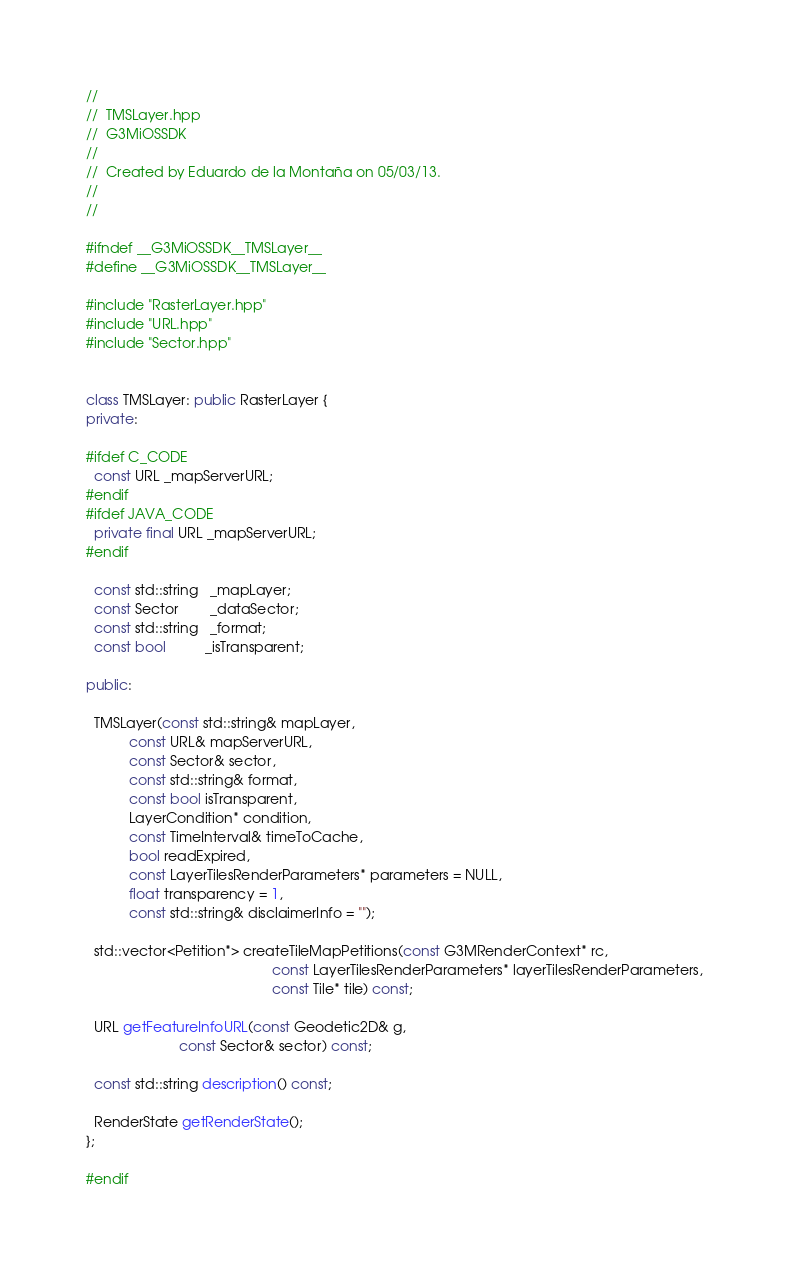<code> <loc_0><loc_0><loc_500><loc_500><_C++_>//
//  TMSLayer.hpp
//  G3MiOSSDK
//
//  Created by Eduardo de la Montaña on 05/03/13.
//
//

#ifndef __G3MiOSSDK__TMSLayer__
#define __G3MiOSSDK__TMSLayer__

#include "RasterLayer.hpp"
#include "URL.hpp"
#include "Sector.hpp"


class TMSLayer: public RasterLayer {
private:

#ifdef C_CODE
  const URL _mapServerURL;
#endif
#ifdef JAVA_CODE
  private final URL _mapServerURL;
#endif

  const std::string   _mapLayer;
  const Sector        _dataSector;
  const std::string   _format;
  const bool          _isTransparent;

public:

  TMSLayer(const std::string& mapLayer,
           const URL& mapServerURL,
           const Sector& sector,
           const std::string& format,
           const bool isTransparent,
           LayerCondition* condition,
           const TimeInterval& timeToCache,
           bool readExpired,
           const LayerTilesRenderParameters* parameters = NULL,
           float transparency = 1,
           const std::string& disclaimerInfo = "");

  std::vector<Petition*> createTileMapPetitions(const G3MRenderContext* rc,
                                                const LayerTilesRenderParameters* layerTilesRenderParameters,
                                                const Tile* tile) const;

  URL getFeatureInfoURL(const Geodetic2D& g,
                        const Sector& sector) const;

  const std::string description() const;

  RenderState getRenderState();
};

#endif
</code> 